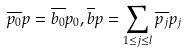<formula> <loc_0><loc_0><loc_500><loc_500>\overline { p _ { 0 } } p = \overline { b _ { 0 } } p _ { 0 } , \overline { b } p = \sum _ { 1 \leq j \leq l } \overline { p _ { j } } p _ { j }</formula> 